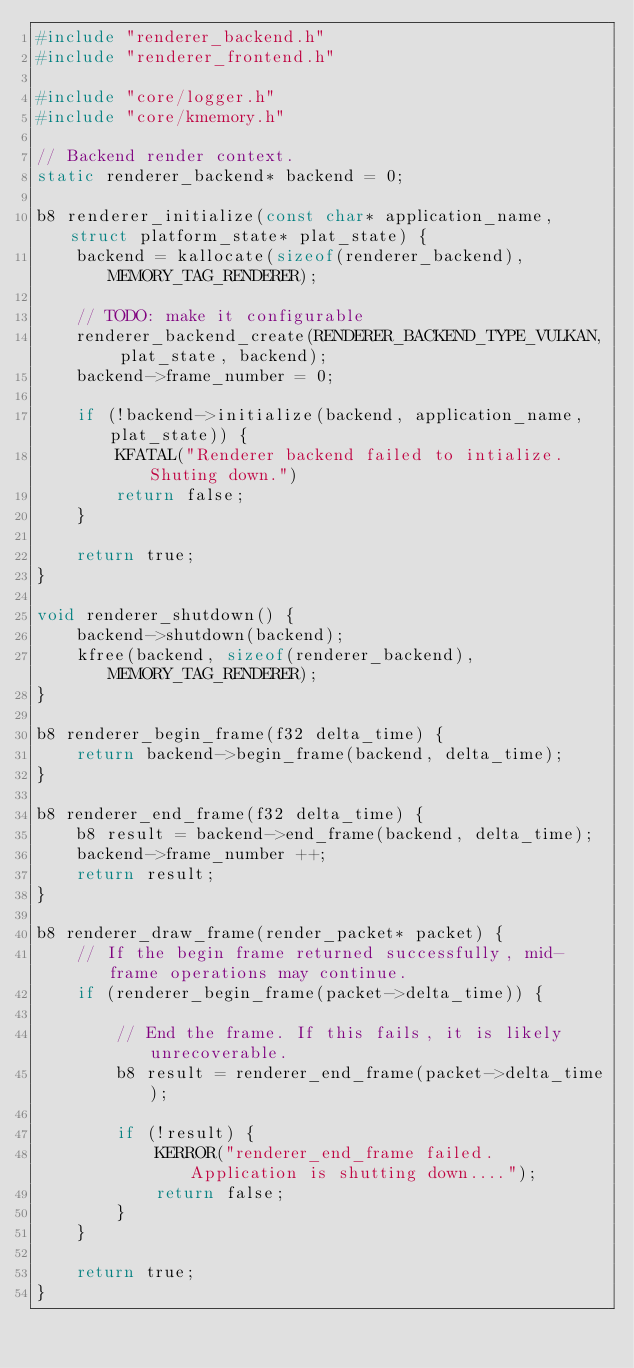<code> <loc_0><loc_0><loc_500><loc_500><_C_>#include "renderer_backend.h"
#include "renderer_frontend.h"

#include "core/logger.h"
#include "core/kmemory.h"

// Backend render context.
static renderer_backend* backend = 0;

b8 renderer_initialize(const char* application_name, struct platform_state* plat_state) {
    backend = kallocate(sizeof(renderer_backend), MEMORY_TAG_RENDERER);

    // TODO: make it configurable
    renderer_backend_create(RENDERER_BACKEND_TYPE_VULKAN, plat_state, backend);
    backend->frame_number = 0;

    if (!backend->initialize(backend, application_name, plat_state)) {
        KFATAL("Renderer backend failed to intialize. Shuting down.")
        return false;
    }

    return true;
}

void renderer_shutdown() {
    backend->shutdown(backend);
    kfree(backend, sizeof(renderer_backend), MEMORY_TAG_RENDERER);
}

b8 renderer_begin_frame(f32 delta_time) {
    return backend->begin_frame(backend, delta_time);
}

b8 renderer_end_frame(f32 delta_time) {
    b8 result = backend->end_frame(backend, delta_time);
    backend->frame_number ++;
    return result;
}

b8 renderer_draw_frame(render_packet* packet) {
    // If the begin frame returned successfully, mid-frame operations may continue.
    if (renderer_begin_frame(packet->delta_time)) {

        // End the frame. If this fails, it is likely unrecoverable.
        b8 result = renderer_end_frame(packet->delta_time);

        if (!result) {
            KERROR("renderer_end_frame failed. Application is shutting down....");
            return false;
        }
    }

    return true;
}</code> 